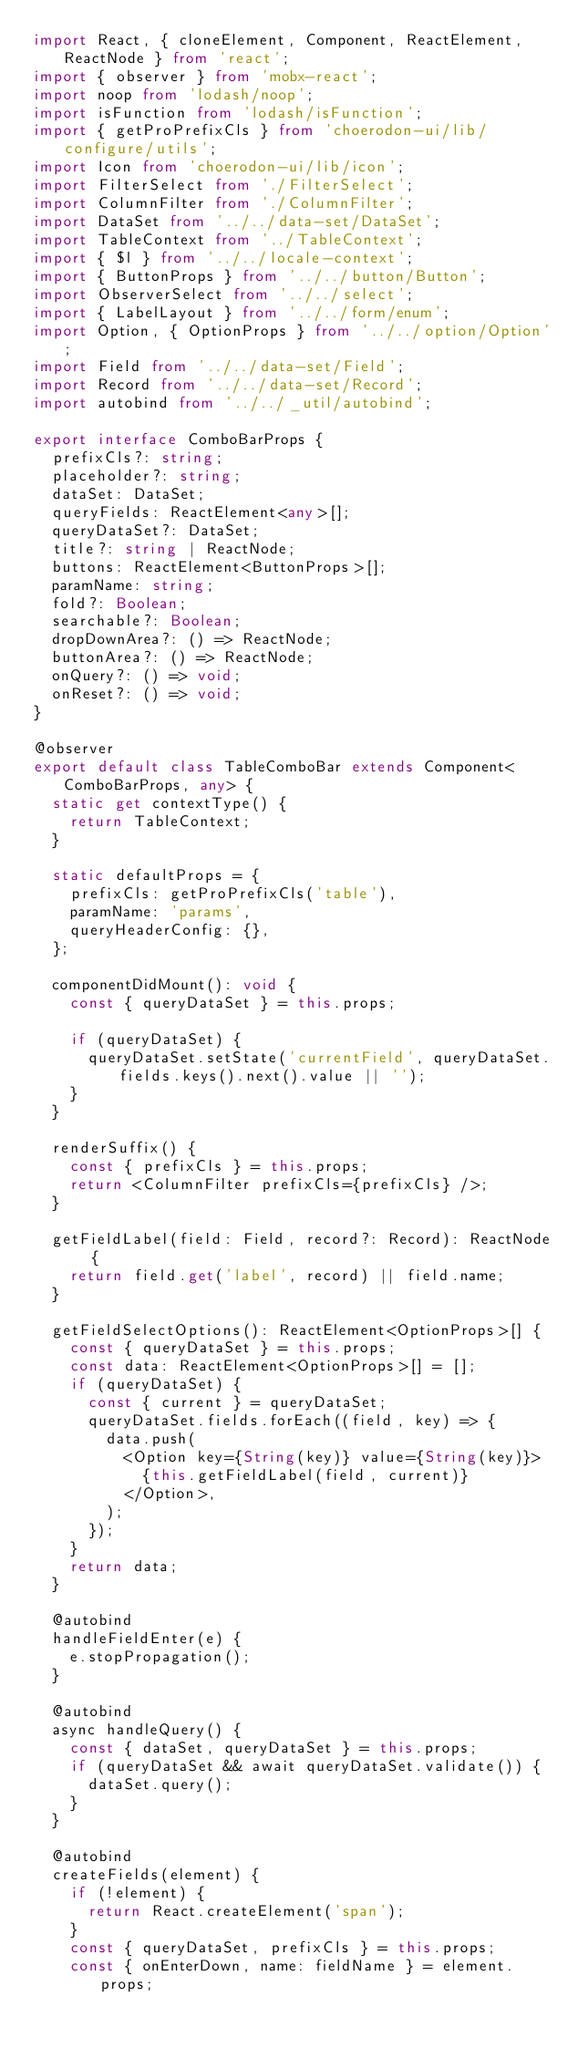Convert code to text. <code><loc_0><loc_0><loc_500><loc_500><_TypeScript_>import React, { cloneElement, Component, ReactElement, ReactNode } from 'react';
import { observer } from 'mobx-react';
import noop from 'lodash/noop';
import isFunction from 'lodash/isFunction';
import { getProPrefixCls } from 'choerodon-ui/lib/configure/utils';
import Icon from 'choerodon-ui/lib/icon';
import FilterSelect from './FilterSelect';
import ColumnFilter from './ColumnFilter';
import DataSet from '../../data-set/DataSet';
import TableContext from '../TableContext';
import { $l } from '../../locale-context';
import { ButtonProps } from '../../button/Button';
import ObserverSelect from '../../select';
import { LabelLayout } from '../../form/enum';
import Option, { OptionProps } from '../../option/Option';
import Field from '../../data-set/Field';
import Record from '../../data-set/Record';
import autobind from '../../_util/autobind';

export interface ComboBarProps {
  prefixCls?: string;
  placeholder?: string;
  dataSet: DataSet;
  queryFields: ReactElement<any>[];
  queryDataSet?: DataSet;
  title?: string | ReactNode;
  buttons: ReactElement<ButtonProps>[];
  paramName: string;
  fold?: Boolean;
  searchable?: Boolean;
  dropDownArea?: () => ReactNode;
  buttonArea?: () => ReactNode;
  onQuery?: () => void;
  onReset?: () => void;
}

@observer
export default class TableComboBar extends Component<ComboBarProps, any> {
  static get contextType() {
    return TableContext;
  }

  static defaultProps = {
    prefixCls: getProPrefixCls('table'),
    paramName: 'params',
    queryHeaderConfig: {},
  };

  componentDidMount(): void {
    const { queryDataSet } = this.props;

    if (queryDataSet) {
      queryDataSet.setState('currentField', queryDataSet.fields.keys().next().value || '');
    }
  }

  renderSuffix() {
    const { prefixCls } = this.props;
    return <ColumnFilter prefixCls={prefixCls} />;
  }

  getFieldLabel(field: Field, record?: Record): ReactNode {
    return field.get('label', record) || field.name;
  }

  getFieldSelectOptions(): ReactElement<OptionProps>[] {
    const { queryDataSet } = this.props;
    const data: ReactElement<OptionProps>[] = [];
    if (queryDataSet) {
      const { current } = queryDataSet;
      queryDataSet.fields.forEach((field, key) => {
        data.push(
          <Option key={String(key)} value={String(key)}>
            {this.getFieldLabel(field, current)}
          </Option>,
        );
      });
    }
    return data;
  }

  @autobind
  handleFieldEnter(e) {
    e.stopPropagation();
  }

  @autobind
  async handleQuery() {
    const { dataSet, queryDataSet } = this.props;
    if (queryDataSet && await queryDataSet.validate()) {
      dataSet.query();
    }
  }

  @autobind
  createFields(element) {
    if (!element) {
      return React.createElement('span');
    }
    const { queryDataSet, prefixCls } = this.props;
    const { onEnterDown, name: fieldName } = element.props;</code> 